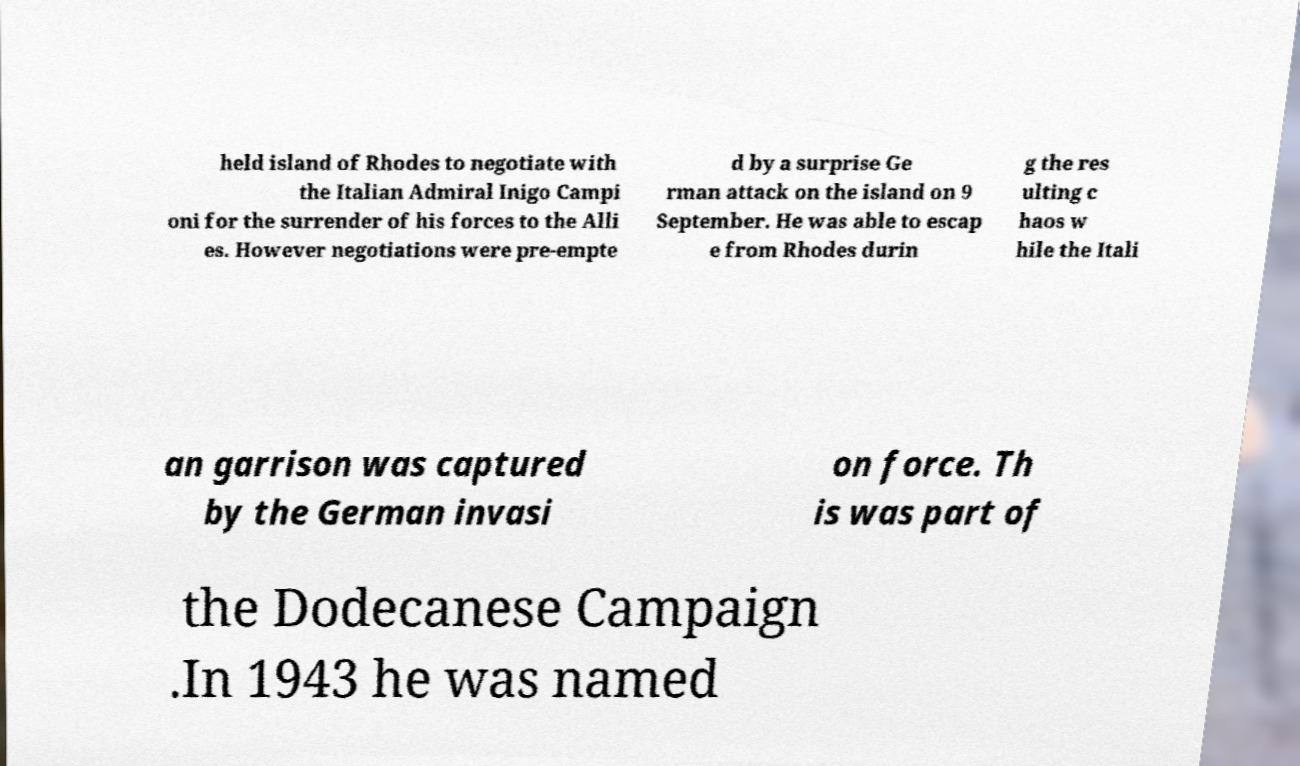Could you assist in decoding the text presented in this image and type it out clearly? held island of Rhodes to negotiate with the Italian Admiral Inigo Campi oni for the surrender of his forces to the Alli es. However negotiations were pre-empte d by a surprise Ge rman attack on the island on 9 September. He was able to escap e from Rhodes durin g the res ulting c haos w hile the Itali an garrison was captured by the German invasi on force. Th is was part of the Dodecanese Campaign .In 1943 he was named 